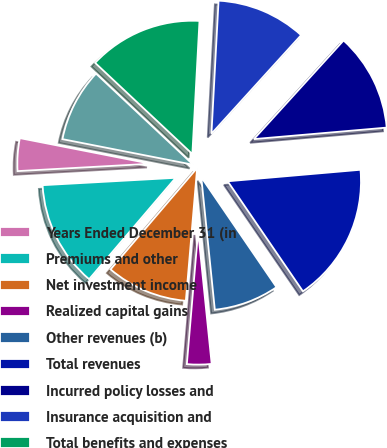<chart> <loc_0><loc_0><loc_500><loc_500><pie_chart><fcel>Years Ended December 31 (in<fcel>Premiums and other<fcel>Net investment income<fcel>Realized capital gains<fcel>Other revenues (b)<fcel>Total revenues<fcel>Incurred policy losses and<fcel>Insurance acquisition and<fcel>Total benefits and expenses<fcel>Income before income taxes<nl><fcel>3.96%<fcel>12.87%<fcel>9.9%<fcel>2.97%<fcel>7.92%<fcel>16.83%<fcel>11.88%<fcel>10.89%<fcel>13.86%<fcel>8.91%<nl></chart> 